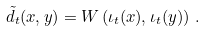Convert formula to latex. <formula><loc_0><loc_0><loc_500><loc_500>\tilde { d } _ { t } ( x , y ) = W \left ( \iota _ { t } ( x ) , \iota _ { t } ( y ) \right ) \, .</formula> 